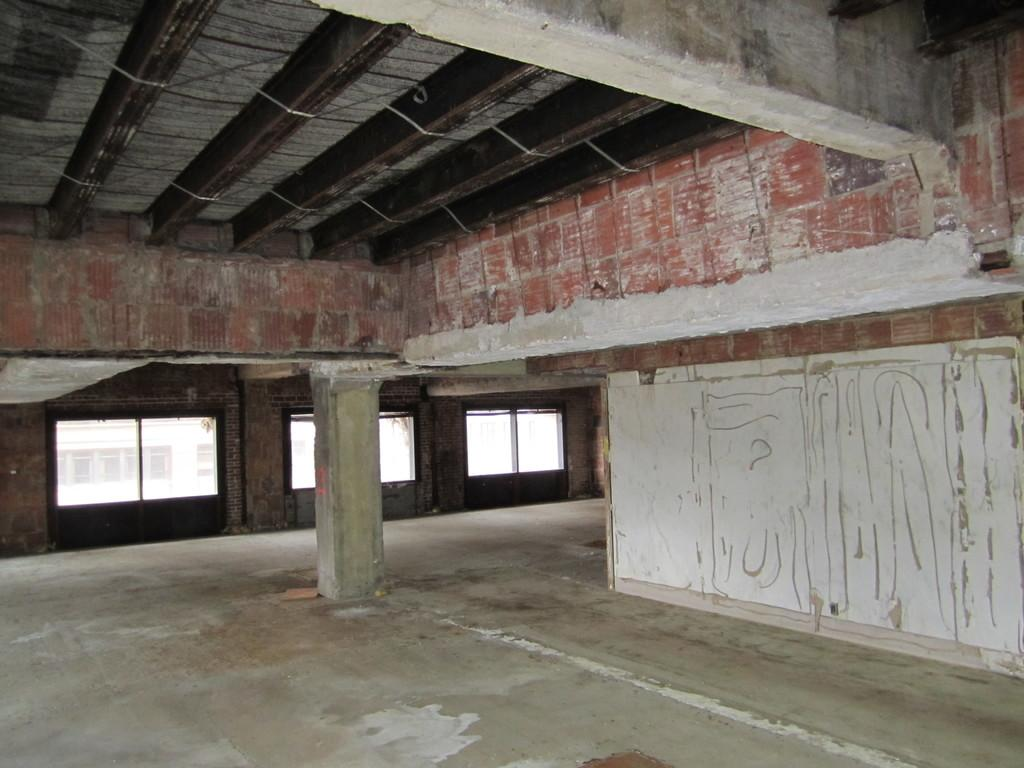What architectural feature can be seen in the image? There is a pillar in the image. What can be seen through the windows in the image? The presence of windows suggests that there is a view or scene visible through them, but the specifics are not mentioned in the facts. What surface is visible in the image? There is a floor in the image. What type of structure is depicted in the image? The presence of a pillar, windows, and a floor suggests that it is an interior space, likely a room or building. What type of trousers is the scarecrow wearing in the image? There is no scarecrow or trousers present in the image. What is the name of the person who created the image? The facts provided do not mention the name of the person who created the image. 